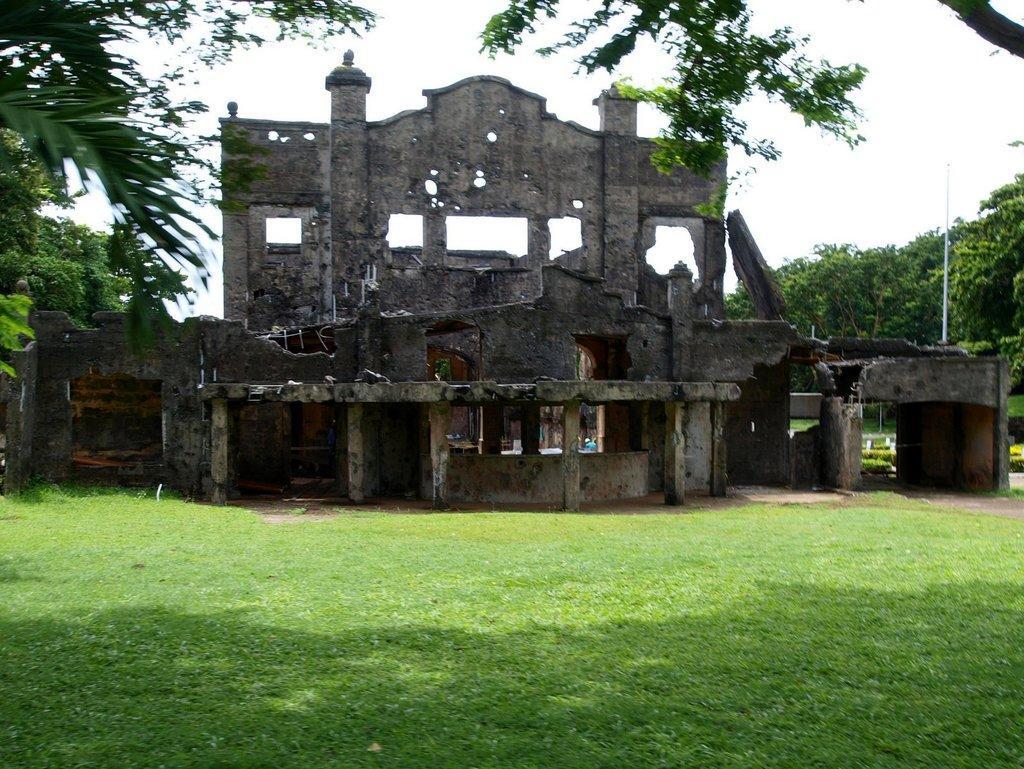Could you give a brief overview of what you see in this image? In this image we can see an old broken building with windows. We can also see some grass, trees, a pole and the sky which looks cloudy. 